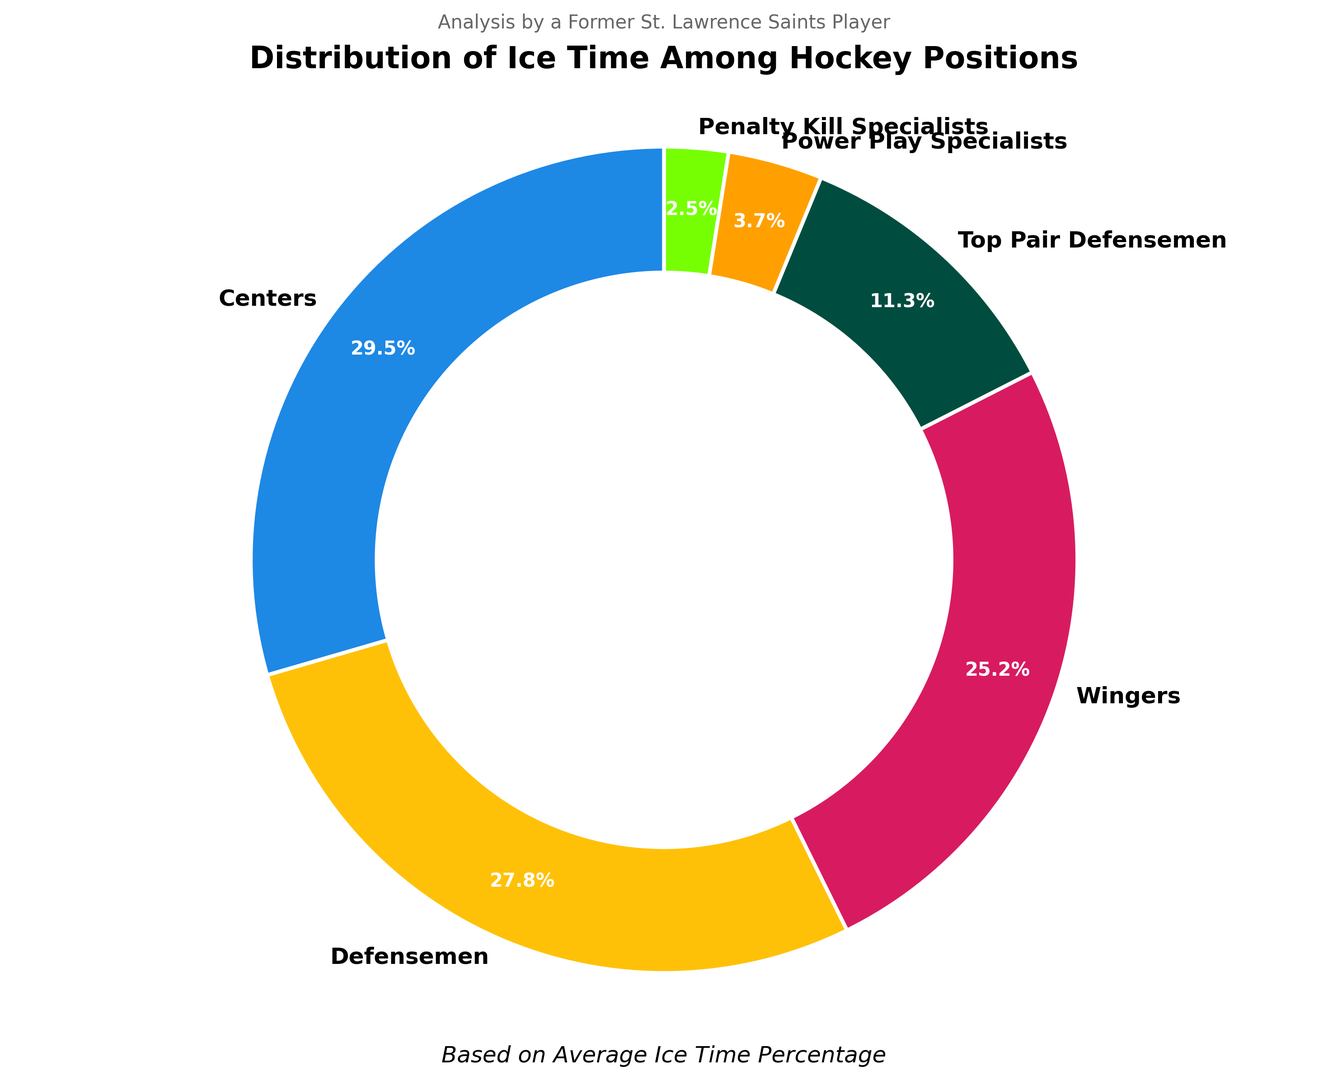What percentage of ice time do the Power Play Specialists and Penalty Kill Specialists together account for? First, find the ice time percentage for the Power Play Specialists (3.7%) and Penalty Kill Specialists (2.5%). Add these values together: 3.7% + 2.5% = 6.2%.
Answer: 6.2% Which position has the highest average ice time percentage? Look at the pie chart to identify the position with the largest wedge or the highest percentage label. Centers account for 29.5% of the average ice time, which is the highest.
Answer: Centers How much more ice time percentage do Wingers have compared to Penalty Kill Specialists? The percentage for Wingers is 25.2% and for Penalty Kill Specialists is 2.5%. Subtract the Penalty Kill Specialists' percentage from Wingers': 25.2% - 2.5% = 22.7%.
Answer: 22.7% What is the average ice time percentage of Defensemen and Top Pair Defensemen combined? Take the percentages for Defensemen (27.8%) and Top Pair Defensemen (11.3%) and add them together: 27.8% + 11.3% = 39.1%.
Answer: 39.1% What color represents the Centers in the pie chart? From the pie chart's visual, you can identify the colors matched to each position by looking at the legend or labels. The Centers are in blue.
Answer: Blue If we exclude Centers from the pie chart, what would the total percentage of ice time among the other positions be? Total percentage is 100%. Subtract the percentage for Centers (29.5%) from 100%: 100% - 29.5% = 70.5%.
Answer: 70.5% Which position has the smallest average ice time percentage, and what is that percentage? By observing the pie chart, Penalty Kill Specialists have the smallest wedge, representing 2.5% of the ice time.
Answer: Penalty Kill Specialists, 2.5% Is the average ice time percentage for Wingers greater than that for Top Pair Defensemen? Check the pie chart to compare the percentages. Wingers have a percentage of 25.2%, while Top Pair Defensemen have 11.3%. 25.2% is greater than 11.3%.
Answer: Yes 